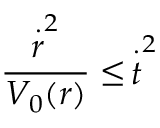<formula> <loc_0><loc_0><loc_500><loc_500>\frac { \stackrel { \cdot } { r } ^ { 2 } } { V _ { 0 } ( r ) } \leq \, \stackrel { \cdot } { t } ^ { 2 }</formula> 